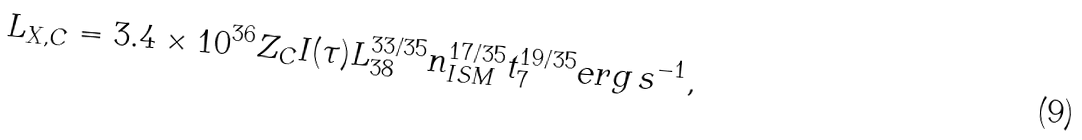Convert formula to latex. <formula><loc_0><loc_0><loc_500><loc_500>L _ { X , C } = 3 . 4 \times 1 0 ^ { 3 6 } Z _ { C } I ( \tau ) L _ { 3 8 } ^ { 3 3 / 3 5 } n _ { I S M } ^ { 1 7 / 3 5 } t _ { 7 } ^ { 1 9 / 3 5 } e r g \, s ^ { - 1 } ,</formula> 